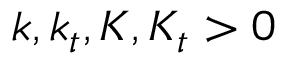Convert formula to latex. <formula><loc_0><loc_0><loc_500><loc_500>k , k _ { t } , K , K _ { t } > 0</formula> 